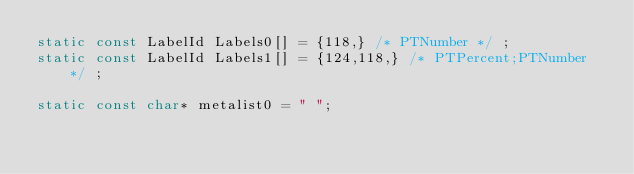<code> <loc_0><loc_0><loc_500><loc_500><_C++_>static const LabelId Labels0[] = {118,} /* PTNumber */ ;
static const LabelId Labels1[] = {124,118,} /* PTPercent;PTNumber */ ;

static const char* metalist0 = " ";
</code> 